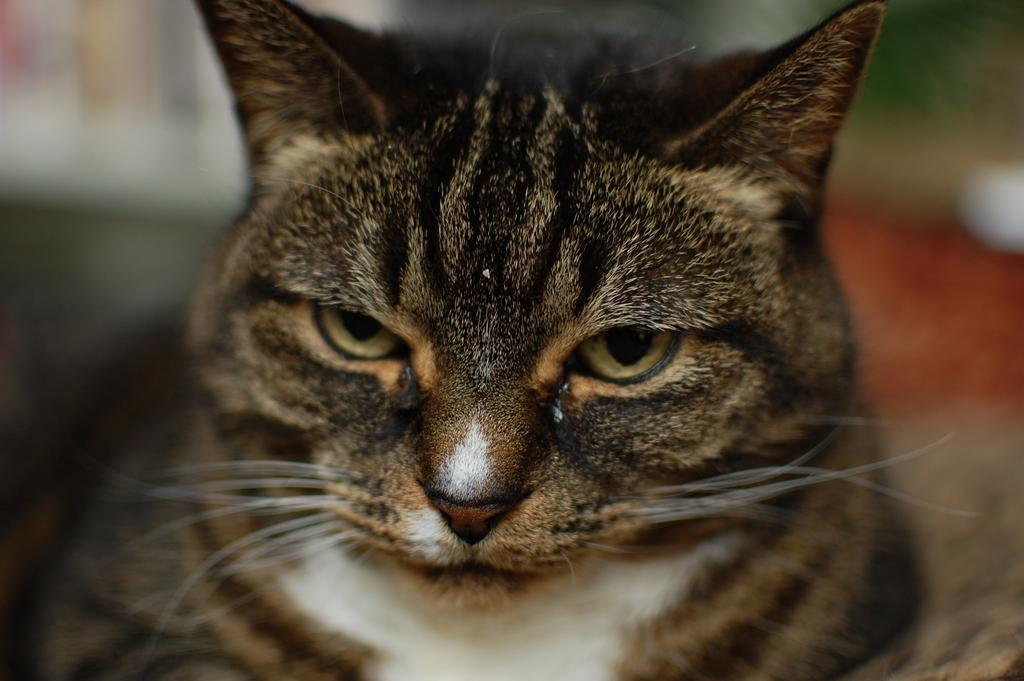What type of animal is present in the image? There is a cat in the image. What color are the stockings worn by the cat in the image? There are no stockings present in the image, as cats do not wear stockings. 